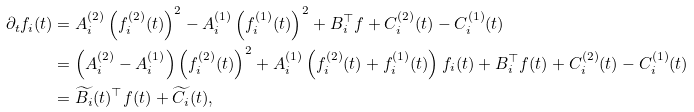Convert formula to latex. <formula><loc_0><loc_0><loc_500><loc_500>\partial _ { t } f _ { i } ( t ) & = A _ { i } ^ { ( 2 ) } \left ( f _ { i } ^ { ( 2 ) } ( t ) \right ) ^ { 2 } - A _ { i } ^ { ( 1 ) } \left ( f _ { i } ^ { ( 1 ) } ( t ) \right ) ^ { 2 } + B _ { i } ^ { \top } f + C ^ { ( 2 ) } _ { i } ( t ) - C ^ { ( 1 ) } _ { i } ( t ) \\ & = \left ( A _ { i } ^ { ( 2 ) } - A _ { i } ^ { ( 1 ) } \right ) \left ( f _ { i } ^ { ( 2 ) } ( t ) \right ) ^ { 2 } + A _ { i } ^ { ( 1 ) } \left ( f _ { i } ^ { ( 2 ) } ( t ) + f _ { i } ^ { ( 1 ) } ( t ) \right ) f _ { i } ( t ) + B _ { i } ^ { \top } f ( t ) + C ^ { ( 2 ) } _ { i } ( t ) - C ^ { ( 1 ) } _ { i } ( t ) \\ & = \widetilde { B _ { i } } ( t ) ^ { \top } f ( t ) + \widetilde { C _ { i } } ( t ) ,</formula> 